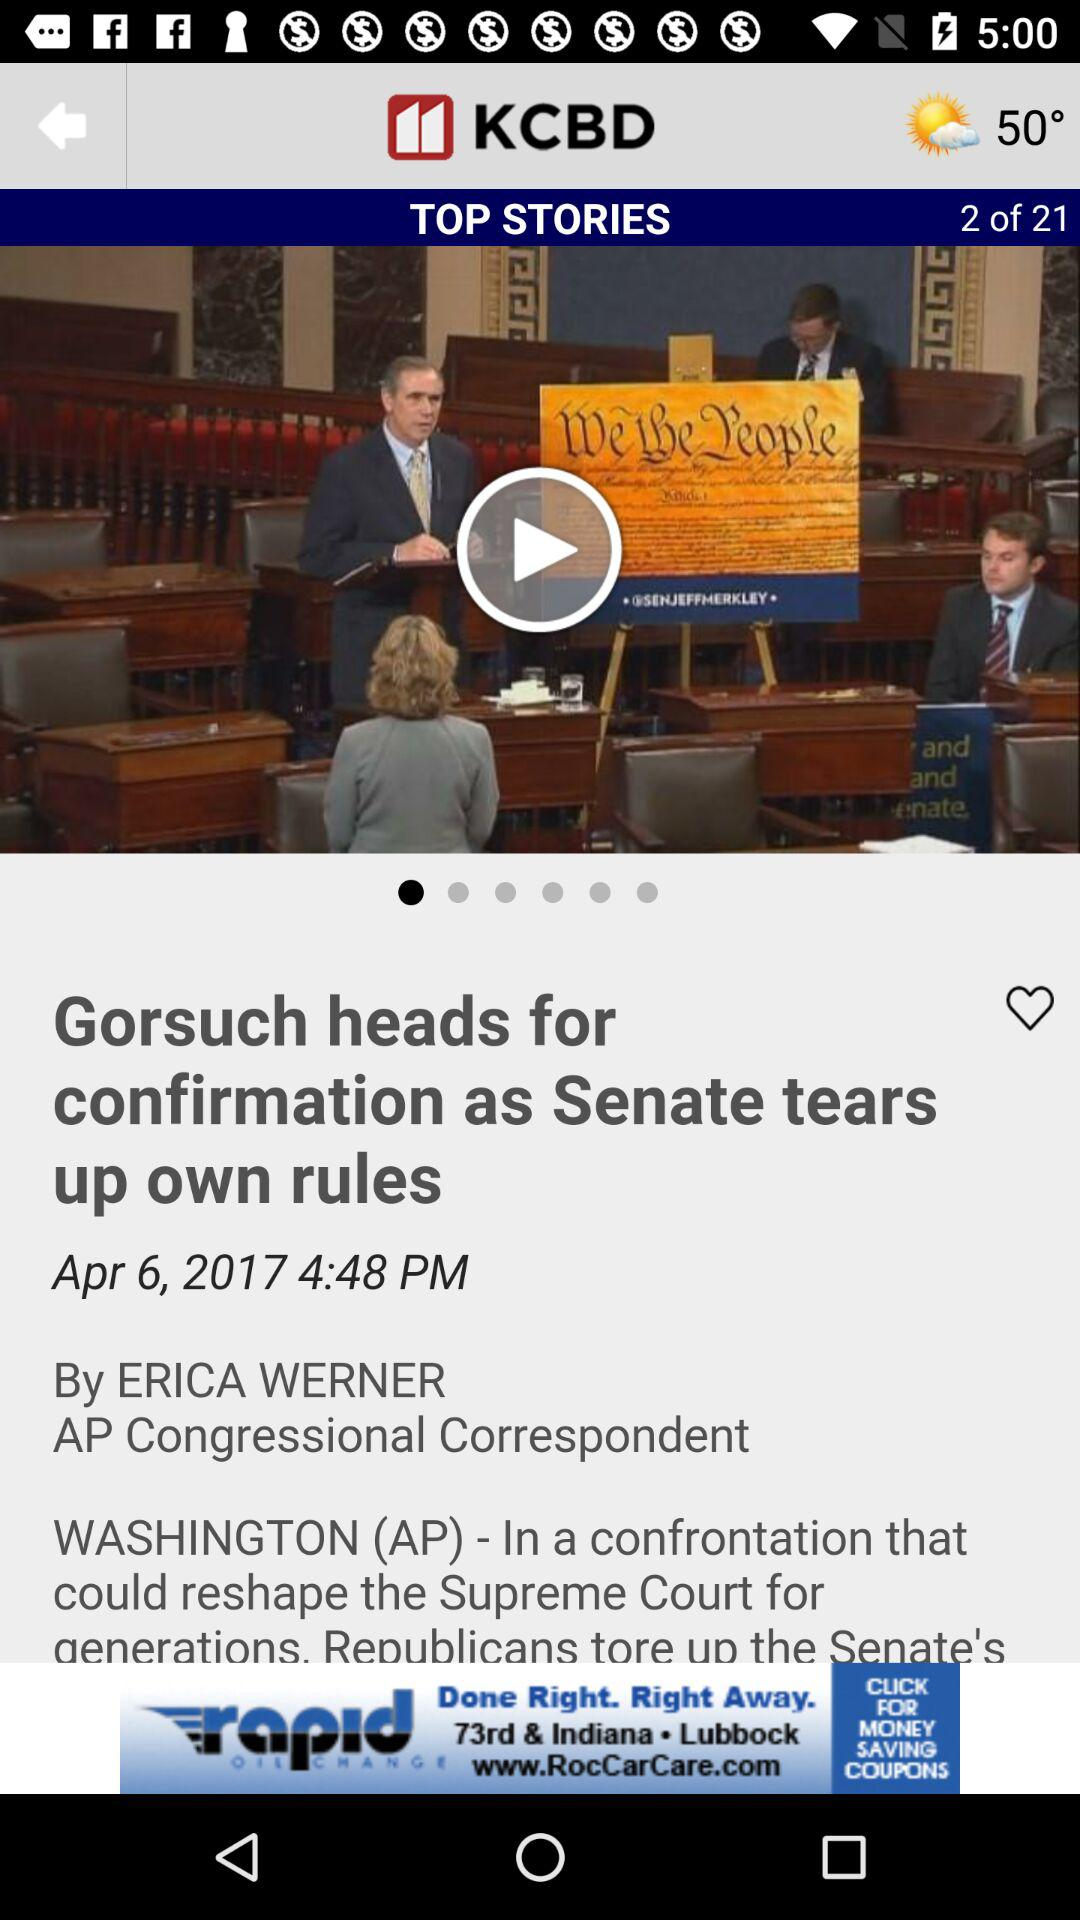Who is the author? The author is Erica Werner. 